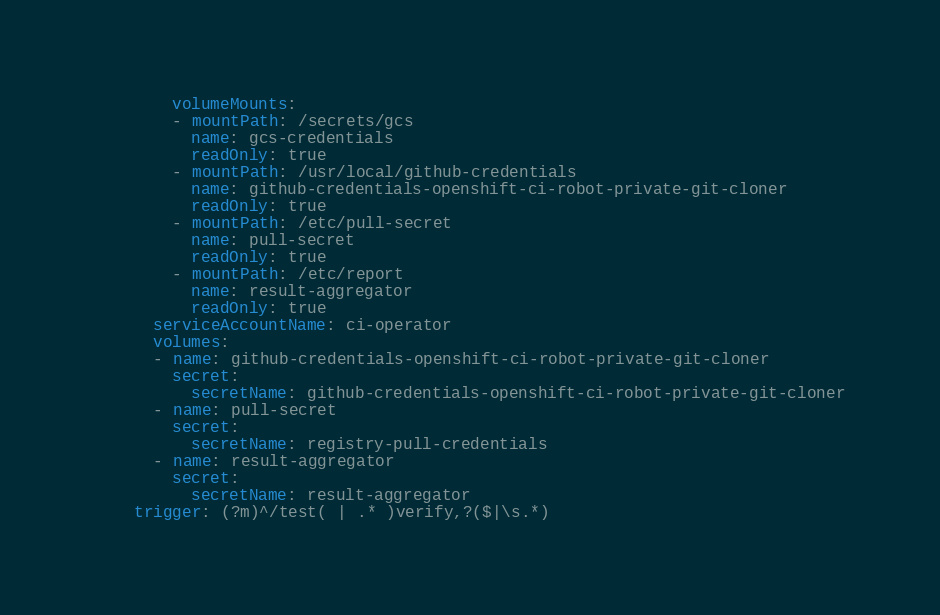Convert code to text. <code><loc_0><loc_0><loc_500><loc_500><_YAML_>        volumeMounts:
        - mountPath: /secrets/gcs
          name: gcs-credentials
          readOnly: true
        - mountPath: /usr/local/github-credentials
          name: github-credentials-openshift-ci-robot-private-git-cloner
          readOnly: true
        - mountPath: /etc/pull-secret
          name: pull-secret
          readOnly: true
        - mountPath: /etc/report
          name: result-aggregator
          readOnly: true
      serviceAccountName: ci-operator
      volumes:
      - name: github-credentials-openshift-ci-robot-private-git-cloner
        secret:
          secretName: github-credentials-openshift-ci-robot-private-git-cloner
      - name: pull-secret
        secret:
          secretName: registry-pull-credentials
      - name: result-aggregator
        secret:
          secretName: result-aggregator
    trigger: (?m)^/test( | .* )verify,?($|\s.*)
</code> 